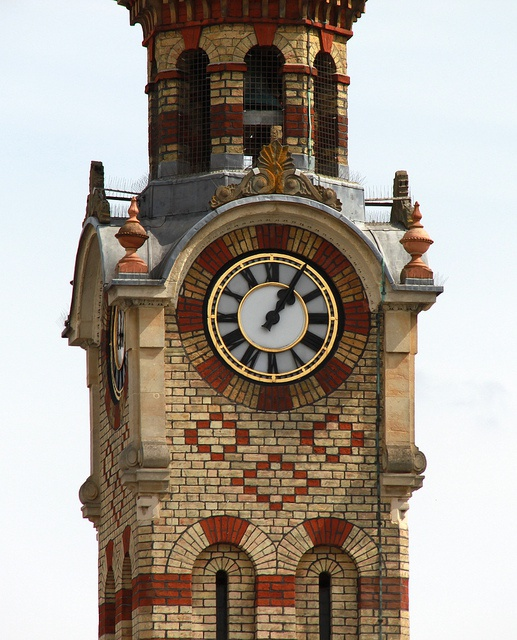Describe the objects in this image and their specific colors. I can see clock in white, black, darkgray, gray, and khaki tones and clock in white, black, gray, and maroon tones in this image. 